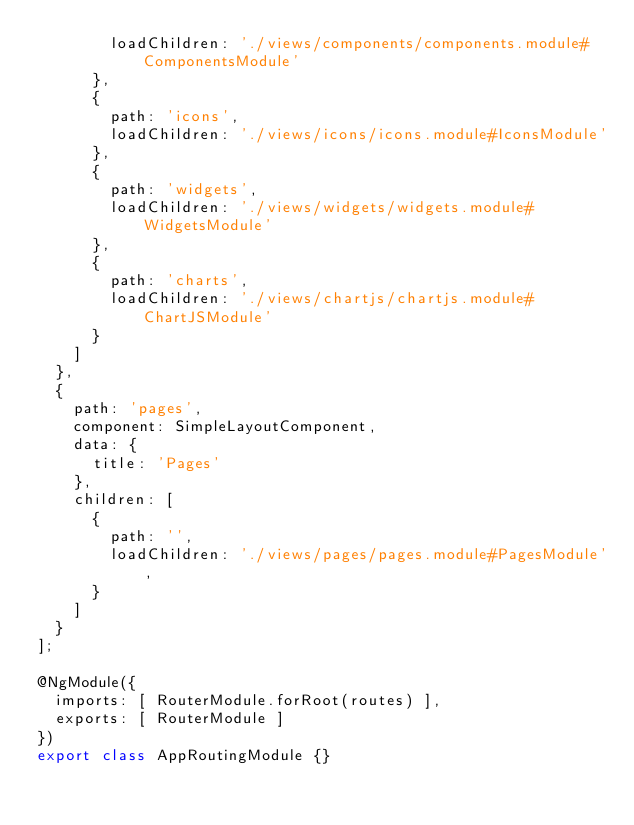Convert code to text. <code><loc_0><loc_0><loc_500><loc_500><_TypeScript_>        loadChildren: './views/components/components.module#ComponentsModule'
      },
      {
        path: 'icons',
        loadChildren: './views/icons/icons.module#IconsModule'
      },
      {
        path: 'widgets',
        loadChildren: './views/widgets/widgets.module#WidgetsModule'
      },
      {
        path: 'charts',
        loadChildren: './views/chartjs/chartjs.module#ChartJSModule'
      }
    ]
  },
  {
    path: 'pages',
    component: SimpleLayoutComponent,
    data: {
      title: 'Pages'
    },
    children: [
      {
        path: '',
        loadChildren: './views/pages/pages.module#PagesModule',
      }
    ]
  }
];

@NgModule({
  imports: [ RouterModule.forRoot(routes) ],
  exports: [ RouterModule ]
})
export class AppRoutingModule {}
</code> 